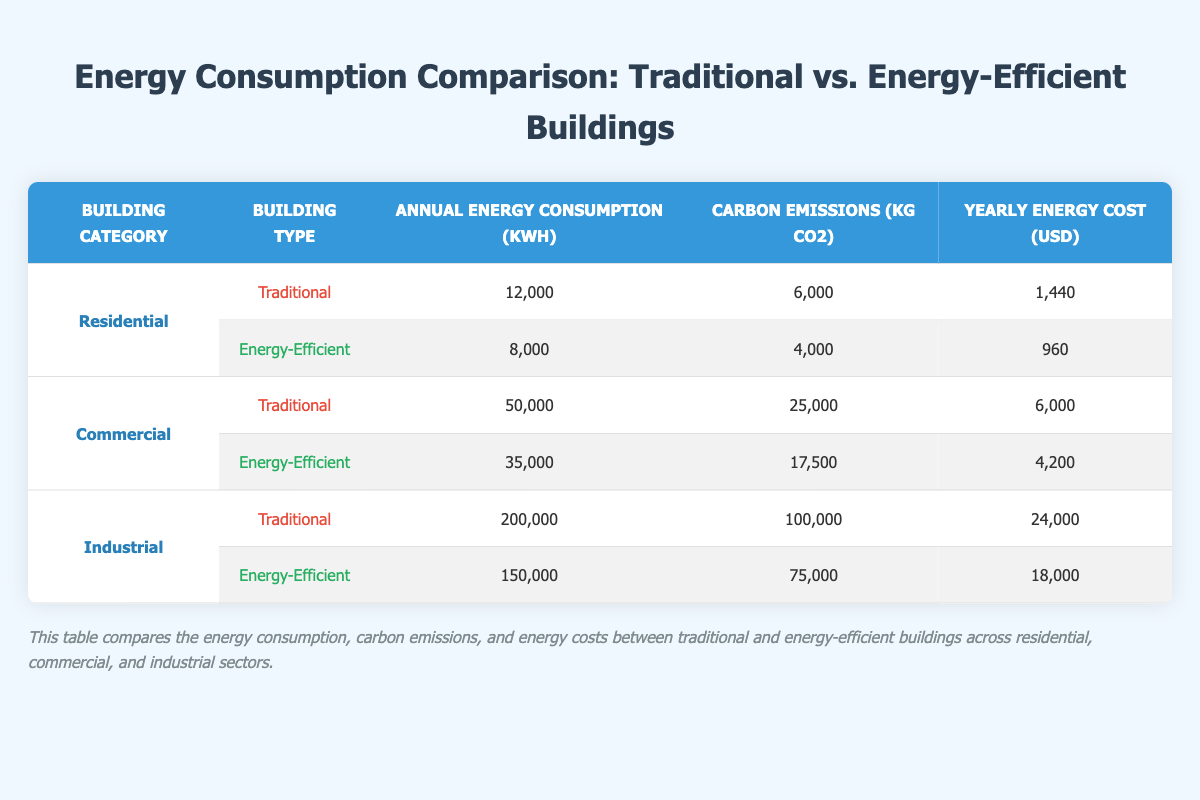What is the annual energy consumption of traditional residential buildings? According to the table, the annual energy consumption for traditional residential buildings is listed as 12,000 kWh.
Answer: 12,000 kWh How much does energy-efficient commercial buildings reduce carbon emissions compared to traditional ones? Traditional commercial buildings emit 25,000 kg CO2, whereas energy-efficient ones emit 17,500 kg CO2. The reduction is 25,000 - 17,500 = 7,500 kg CO2.
Answer: 7,500 kg CO2 What is the yearly energy cost for energy-efficient buildings in the industrial sector? The table shows that the yearly energy cost for energy-efficient industrial buildings is 18,000 USD.
Answer: 18,000 USD Do energy-efficient buildings in the residential category consume more or less energy than traditional buildings? The energy-efficient residential buildings consume 8,000 kWh, while traditional residential buildings consume 12,000 kWh, which means energy-efficient buildings consume less energy.
Answer: Less What is the total annual energy consumption for traditional buildings across all sectors? To find this, we sum the energy consumption for traditional buildings: 12,000 (residential) + 50,000 (commercial) + 200,000 (industrial) = 262,000 kWh.
Answer: 262,000 kWh What is the average yearly energy cost for traditional buildings across all categories? The yearly energy costs for traditional buildings are 1,440 (residential) + 6,000 (commercial) + 24,000 (industrial) = 31,440 USD. There are 3 categories, so the average is 31,440 USD / 3 = 10,480 USD.
Answer: 10,480 USD Is the carbon emission from energy-efficient buildings in the industrial sector lower than that in the residential sector? Energy-efficient industrial buildings emit 75,000 kg CO2, while energy-efficient residential buildings emit 4,000 kg CO2. Since 75,000 kg CO2 is greater than 4,000 kg CO2, the statement is false.
Answer: No How much energy is saved annually in the commercial sector by using energy-efficient buildings instead of traditional ones? The difference in annual energy consumption is 50,000 kWh (traditional) - 35,000 kWh (energy-efficient) = 15,000 kWh saved annually in the commercial sector.
Answer: 15,000 kWh What percentage of carbon emissions do energy-efficient industrial buildings represent compared to traditional industrial buildings? The carbon emissions for traditional industrial buildings are 100,000 kg CO2, and for energy-efficient industrial buildings, it's 75,000 kg CO2. The percentage is (75,000 / 100,000) * 100 = 75%.
Answer: 75% 